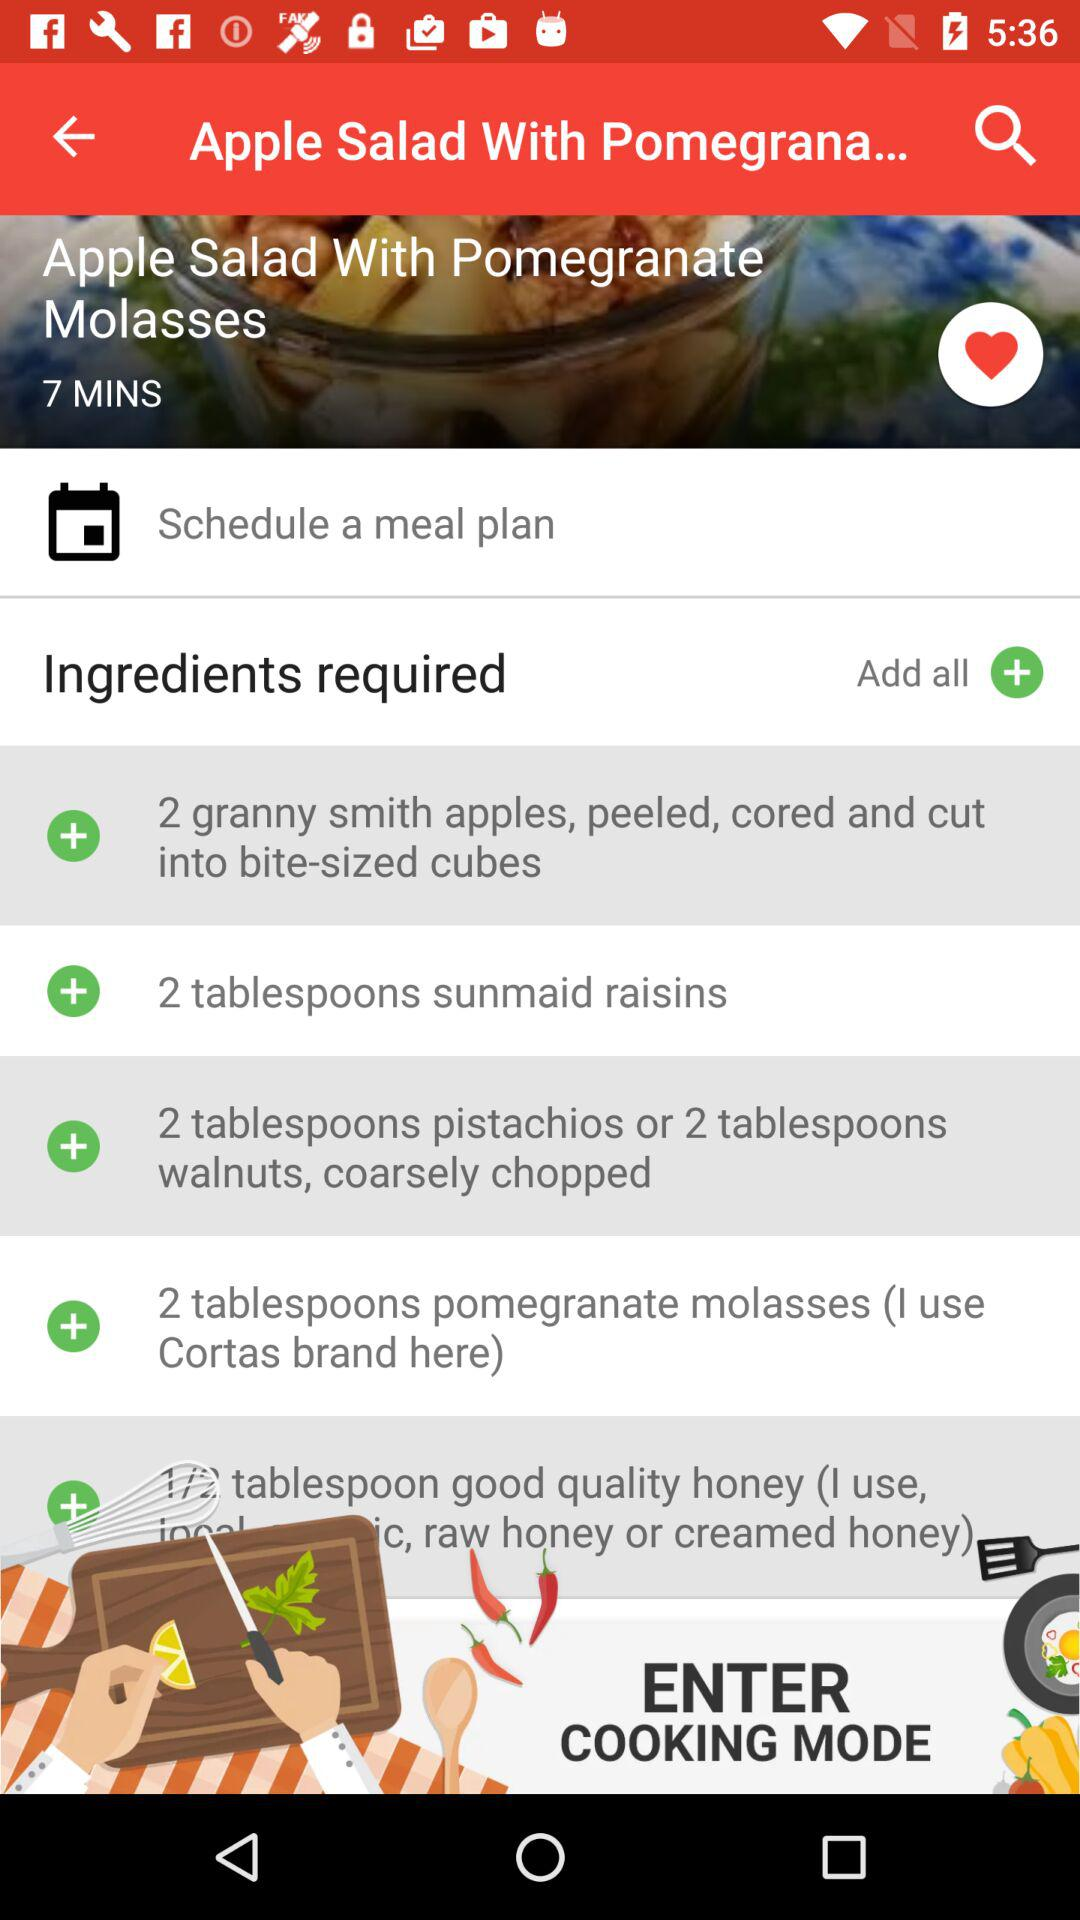What is the duration for making "Apple Salad With Pomegranate Molasses"? The duration is 7 minutes. 